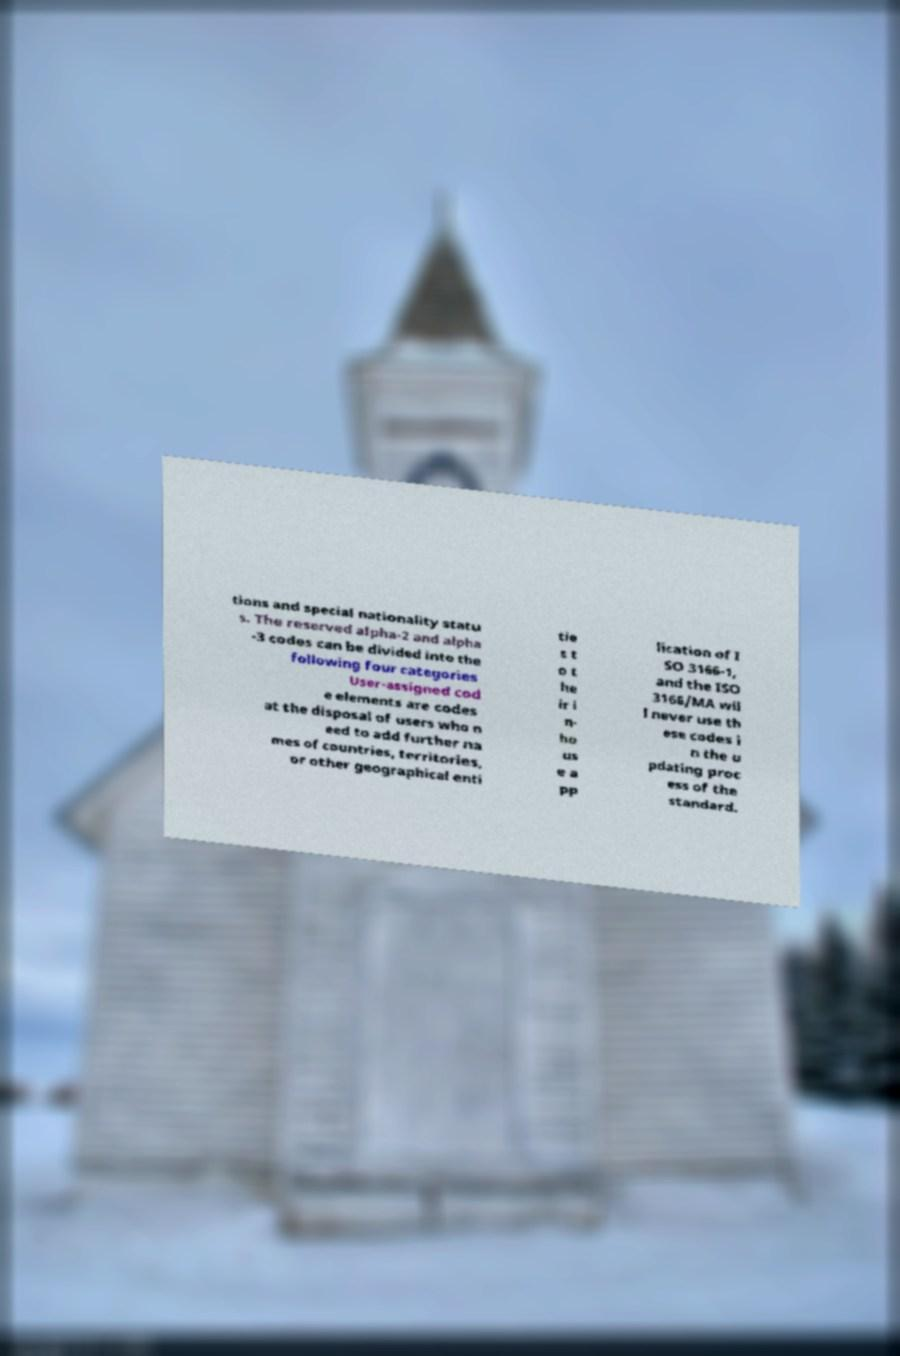I need the written content from this picture converted into text. Can you do that? tions and special nationality statu s. The reserved alpha-2 and alpha -3 codes can be divided into the following four categories User-assigned cod e elements are codes at the disposal of users who n eed to add further na mes of countries, territories, or other geographical enti tie s t o t he ir i n- ho us e a pp lication of I SO 3166-1, and the ISO 3166/MA wil l never use th ese codes i n the u pdating proc ess of the standard. 